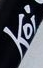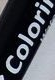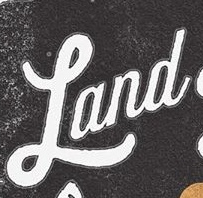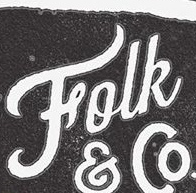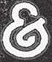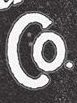Read the text content from these images in order, separated by a semicolon. Koi; Colori; Land; Folk; &; Co 